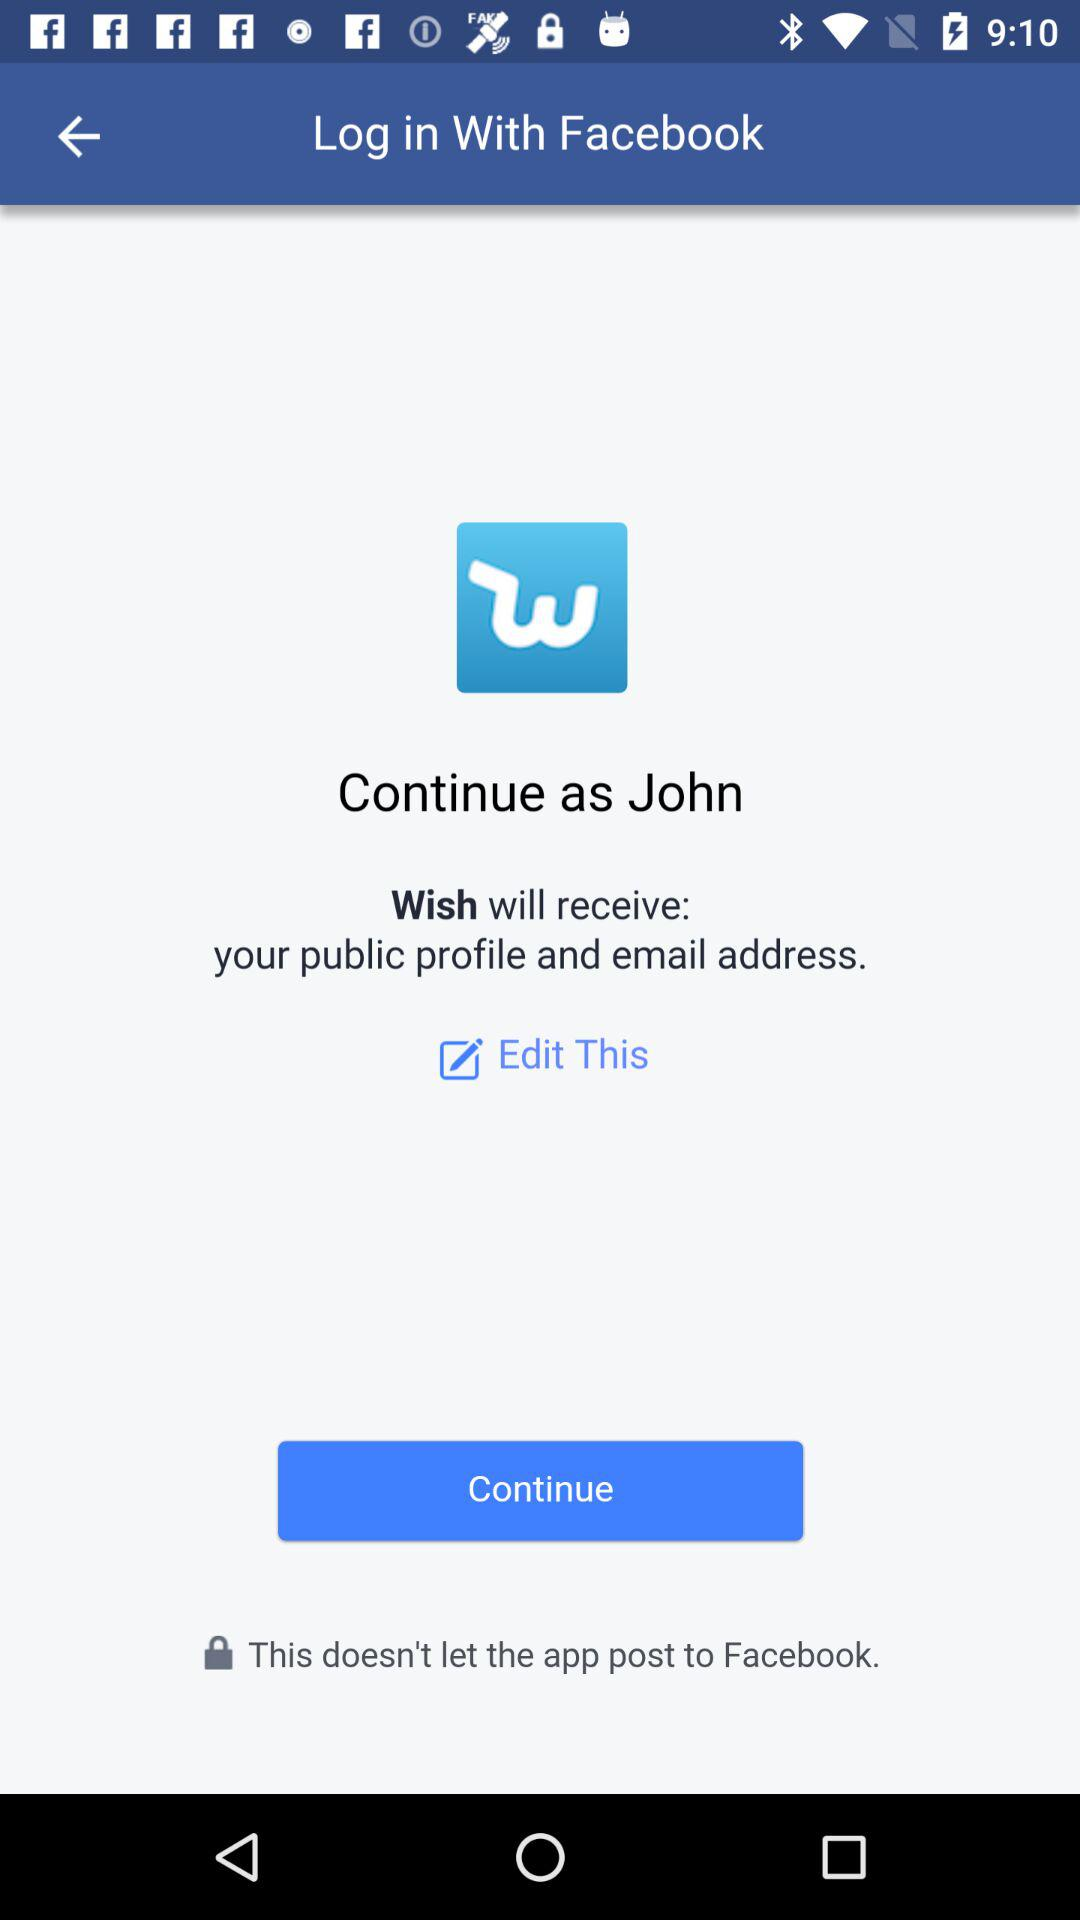What is the user name? The user name is John. 